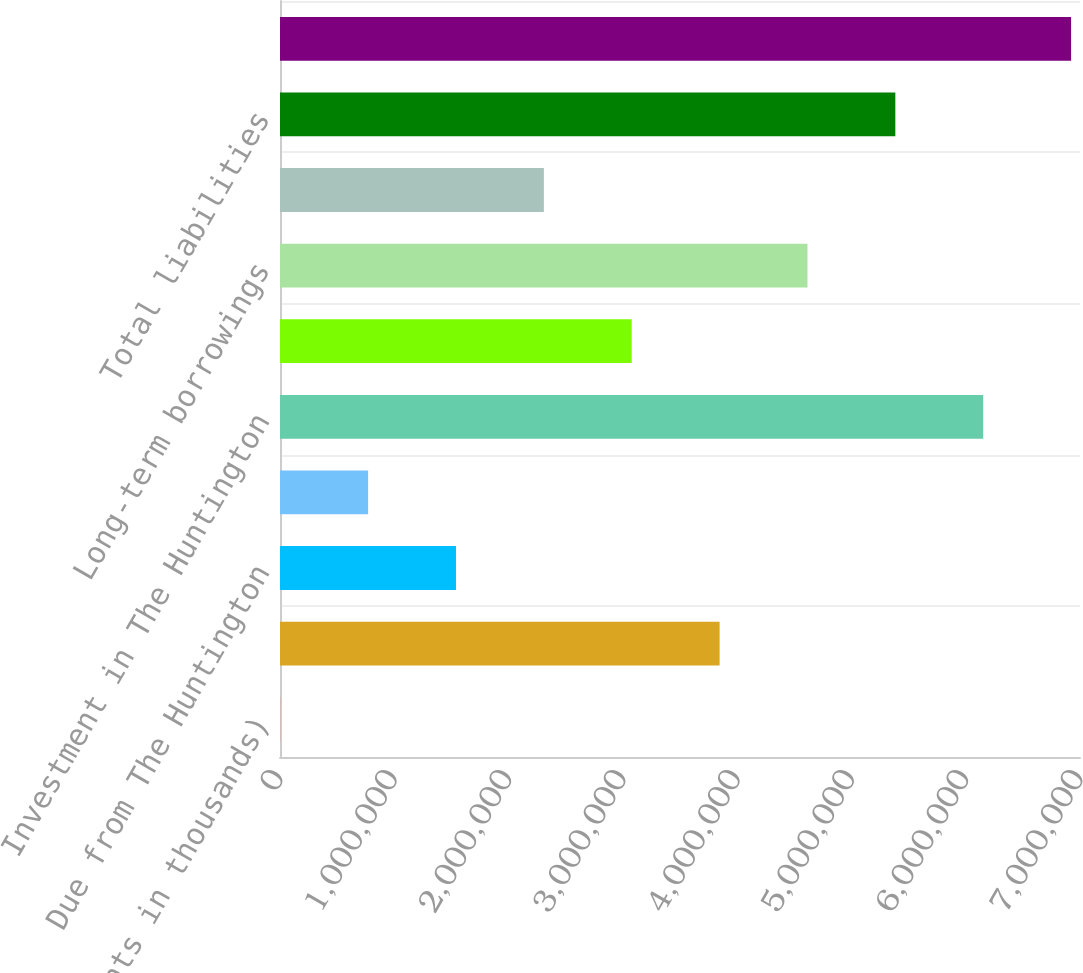Convert chart. <chart><loc_0><loc_0><loc_500><loc_500><bar_chart><fcel>(dollar amounts in thousands)<fcel>Cash and cash equivalents<fcel>Due from The Huntington<fcel>Due from non-bank subsidiaries<fcel>Investment in The Huntington<fcel>Investment in non-bank<fcel>Long-term borrowings<fcel>Dividends payable accrued<fcel>Total liabilities<fcel>Shareholders' equity (2)<nl><fcel>2013<fcel>3.84642e+06<fcel>1.53978e+06<fcel>770895<fcel>6.15307e+06<fcel>3.07754e+06<fcel>4.6153e+06<fcel>2.30866e+06<fcel>5.38418e+06<fcel>6.92195e+06<nl></chart> 